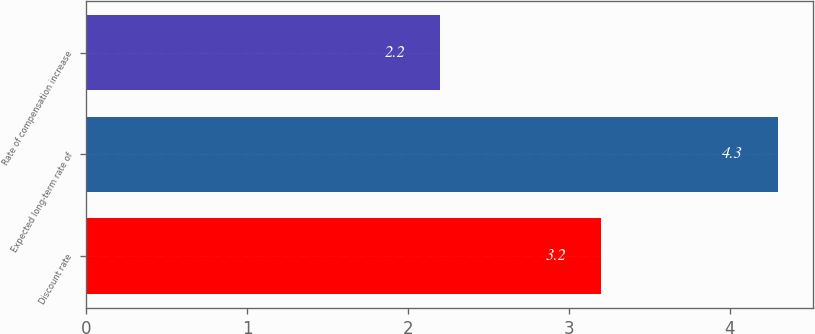Convert chart. <chart><loc_0><loc_0><loc_500><loc_500><bar_chart><fcel>Discount rate<fcel>Expected long-term rate of<fcel>Rate of compensation increase<nl><fcel>3.2<fcel>4.3<fcel>2.2<nl></chart> 